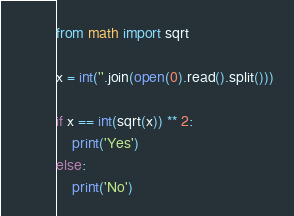<code> <loc_0><loc_0><loc_500><loc_500><_Python_>from math import sqrt

x = int(''.join(open(0).read().split()))

if x == int(sqrt(x)) ** 2:
    print('Yes')
else:
    print('No')</code> 